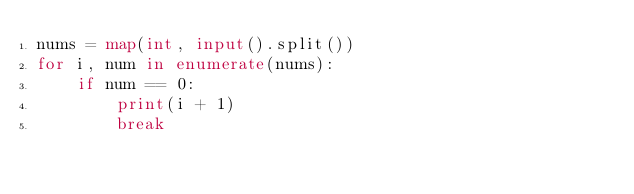<code> <loc_0><loc_0><loc_500><loc_500><_Python_>nums = map(int, input().split())
for i, num in enumerate(nums):
	if num == 0:
		print(i + 1)
		break
</code> 